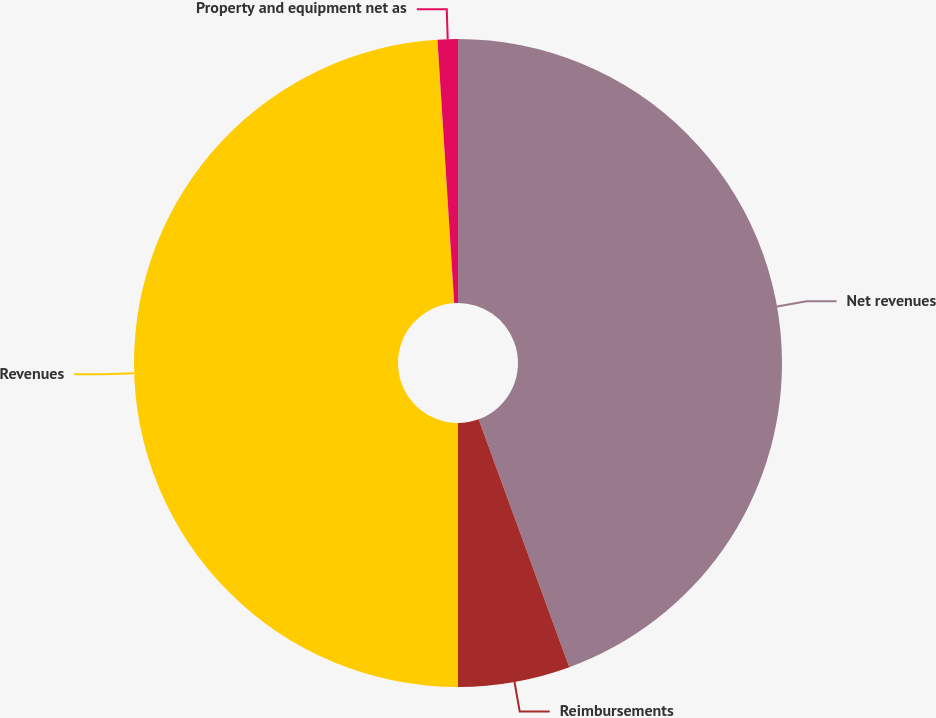<chart> <loc_0><loc_0><loc_500><loc_500><pie_chart><fcel>Net revenues<fcel>Reimbursements<fcel>Revenues<fcel>Property and equipment net as<nl><fcel>44.42%<fcel>5.58%<fcel>48.99%<fcel>1.01%<nl></chart> 